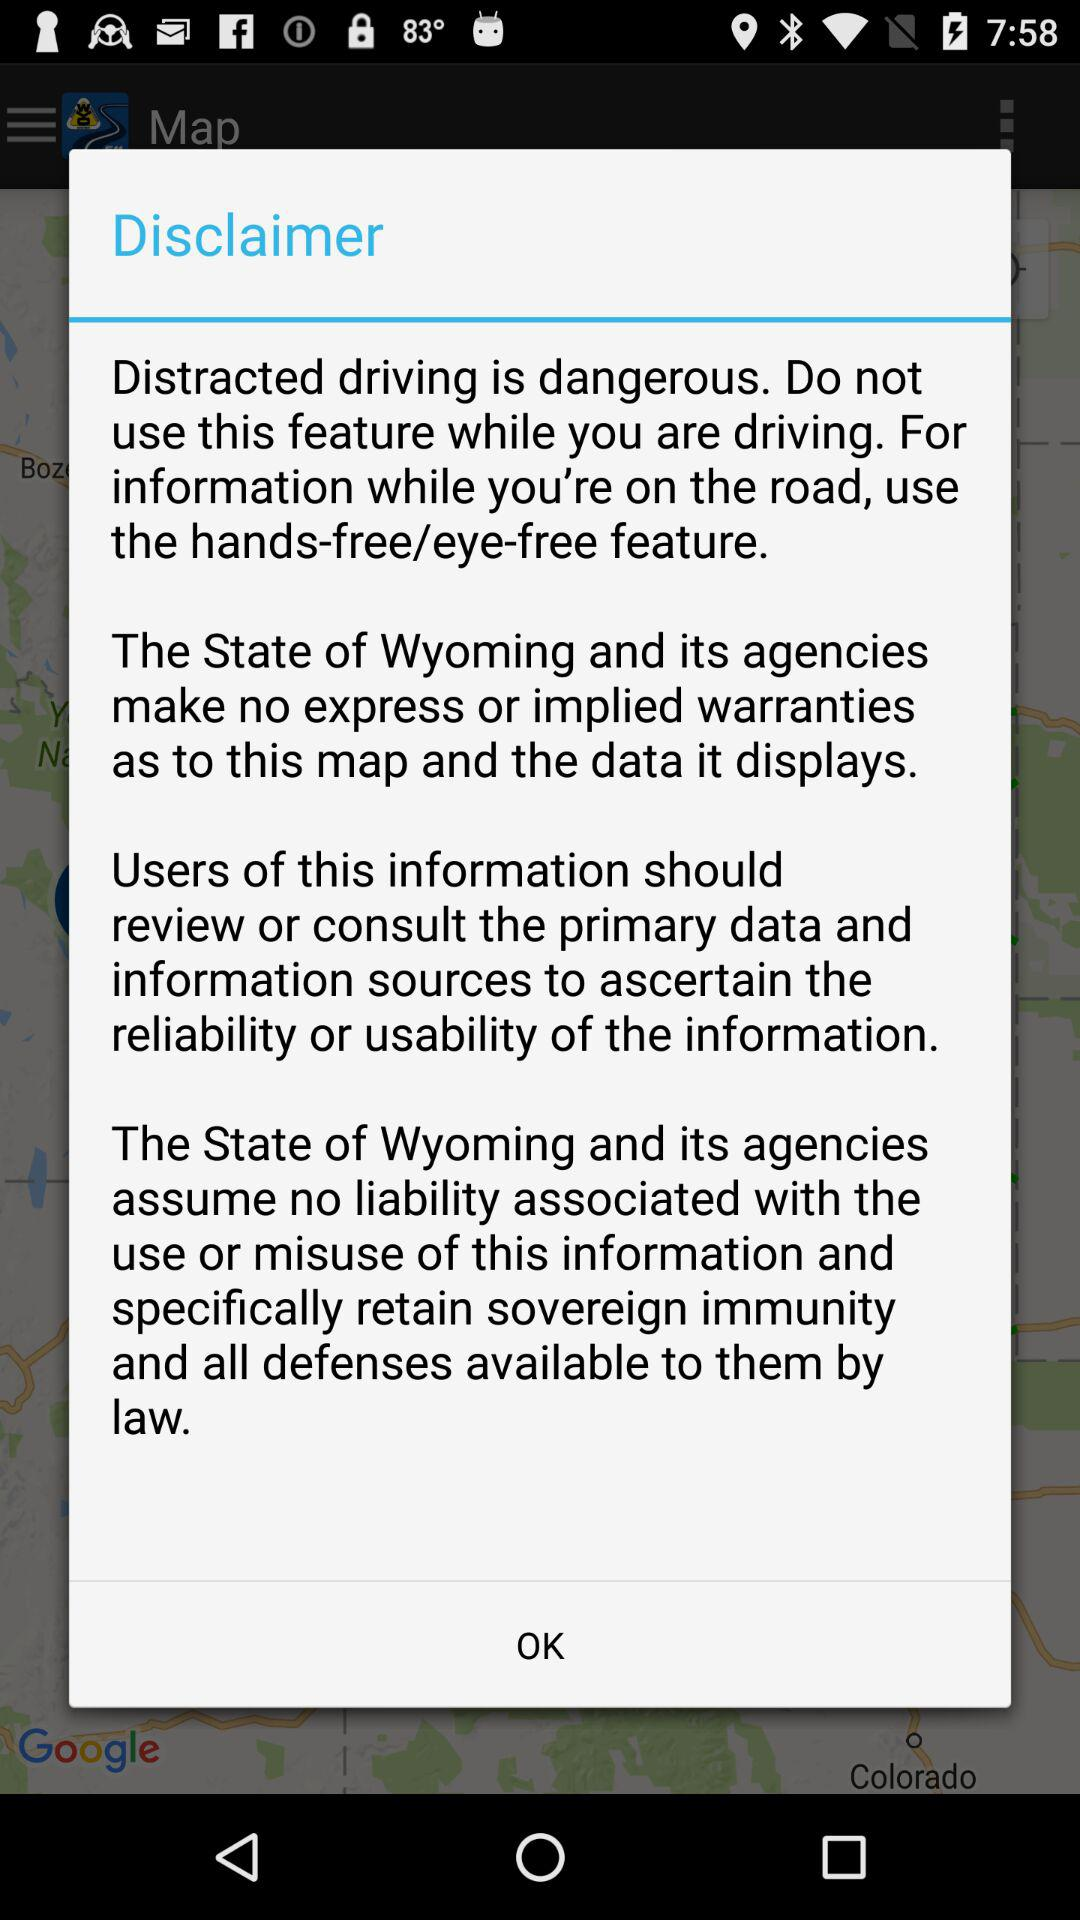How many sentences are there in the disclaimer?
Answer the question using a single word or phrase. 4 